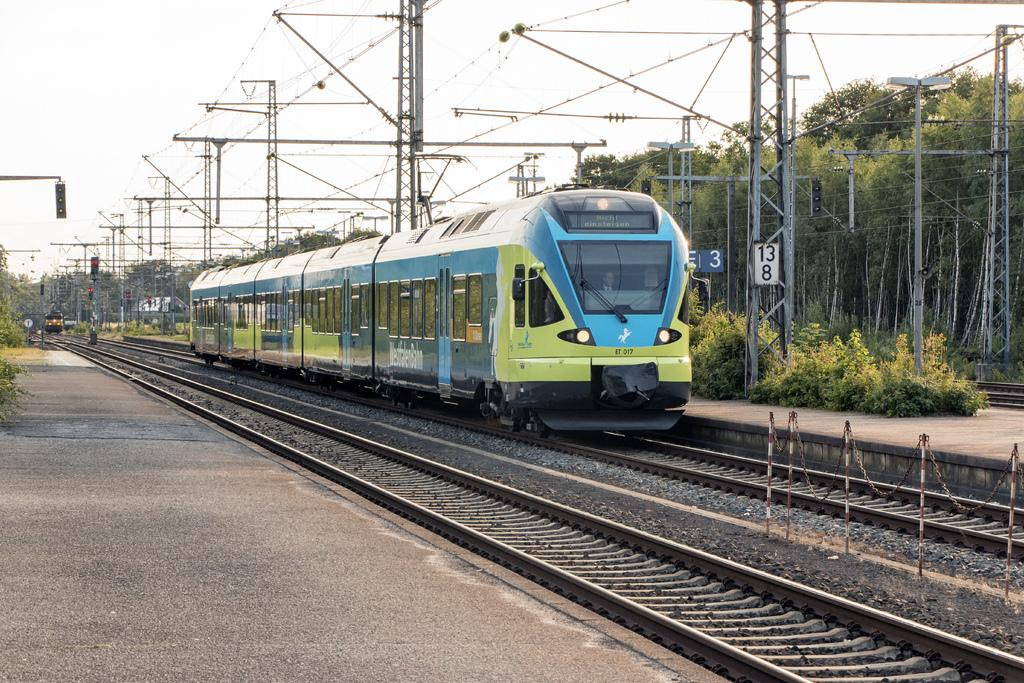What is the main subject of the image? The main subject of the image is a train. What is the train doing in the image? The train is moving on a railway track. What is the color of the train? The train is blue in color. What can be seen on the left side of the image? There is a platform on the left side of the image. What type of vegetation is on the right side of the image? There are green trees on the right side of the image. What is visible at the top of the image? The sky is visible at the top of the image. How much money is being exchanged between the passengers on the train in the image? There is no indication of money exchange or passengers in the image; it only shows a blue train moving on a railway track. 